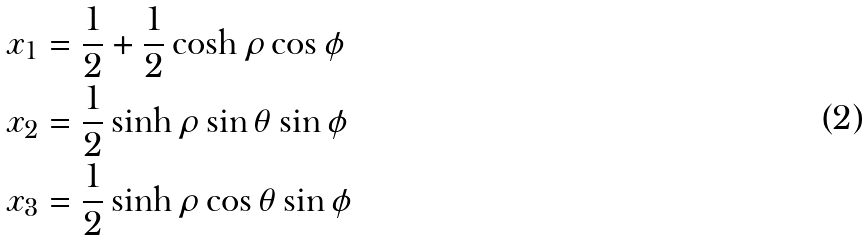Convert formula to latex. <formula><loc_0><loc_0><loc_500><loc_500>x _ { 1 } & = \frac { 1 } { 2 } + \frac { 1 } { 2 } \cosh \rho \cos \phi \\ x _ { 2 } & = \frac { 1 } { 2 } \sinh \rho \sin \theta \sin \phi \\ x _ { 3 } & = \frac { 1 } { 2 } \sinh \rho \cos \theta \sin \phi \\</formula> 